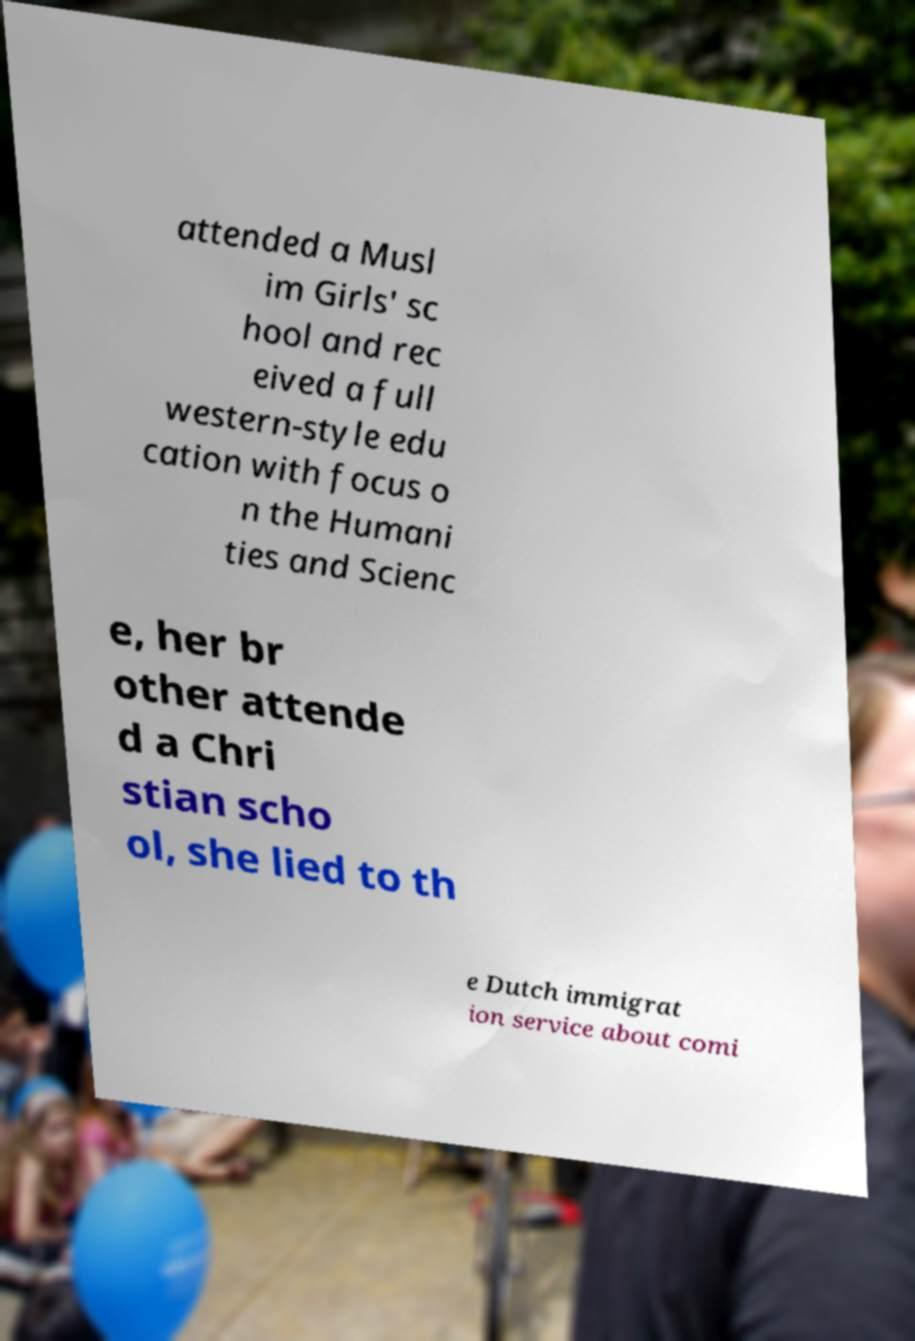Please read and relay the text visible in this image. What does it say? attended a Musl im Girls' sc hool and rec eived a full western-style edu cation with focus o n the Humani ties and Scienc e, her br other attende d a Chri stian scho ol, she lied to th e Dutch immigrat ion service about comi 